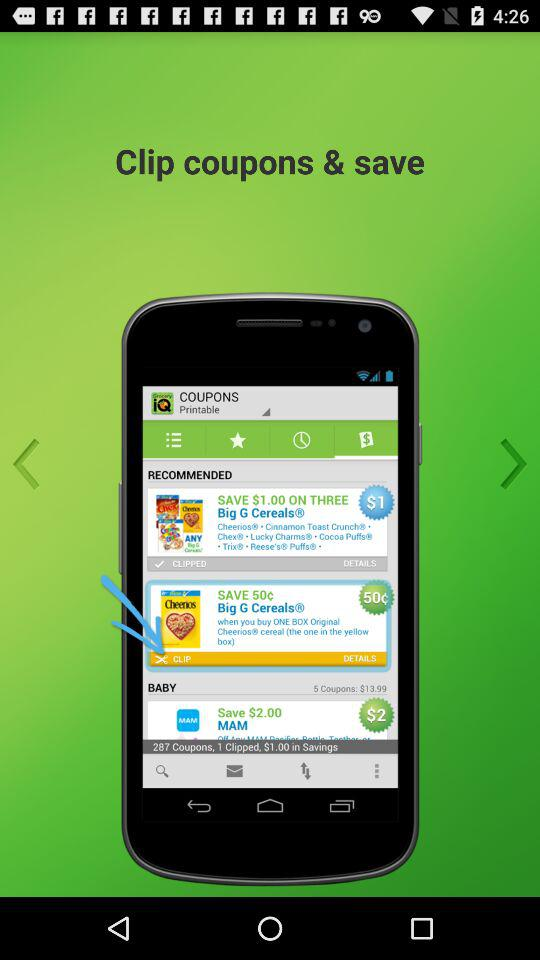How many more backward arrows are there than forward arrows?
Answer the question using a single word or phrase. 1 